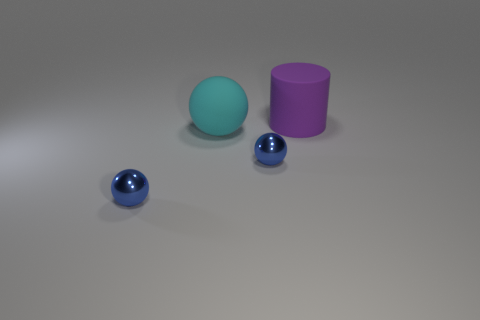Subtract all gray blocks. How many blue spheres are left? 2 Subtract all blue spheres. How many spheres are left? 1 Add 2 large objects. How many objects exist? 6 Subtract all cylinders. How many objects are left? 3 Add 4 cylinders. How many cylinders exist? 5 Subtract 0 red balls. How many objects are left? 4 Subtract all small balls. Subtract all rubber spheres. How many objects are left? 1 Add 4 large matte cylinders. How many large matte cylinders are left? 5 